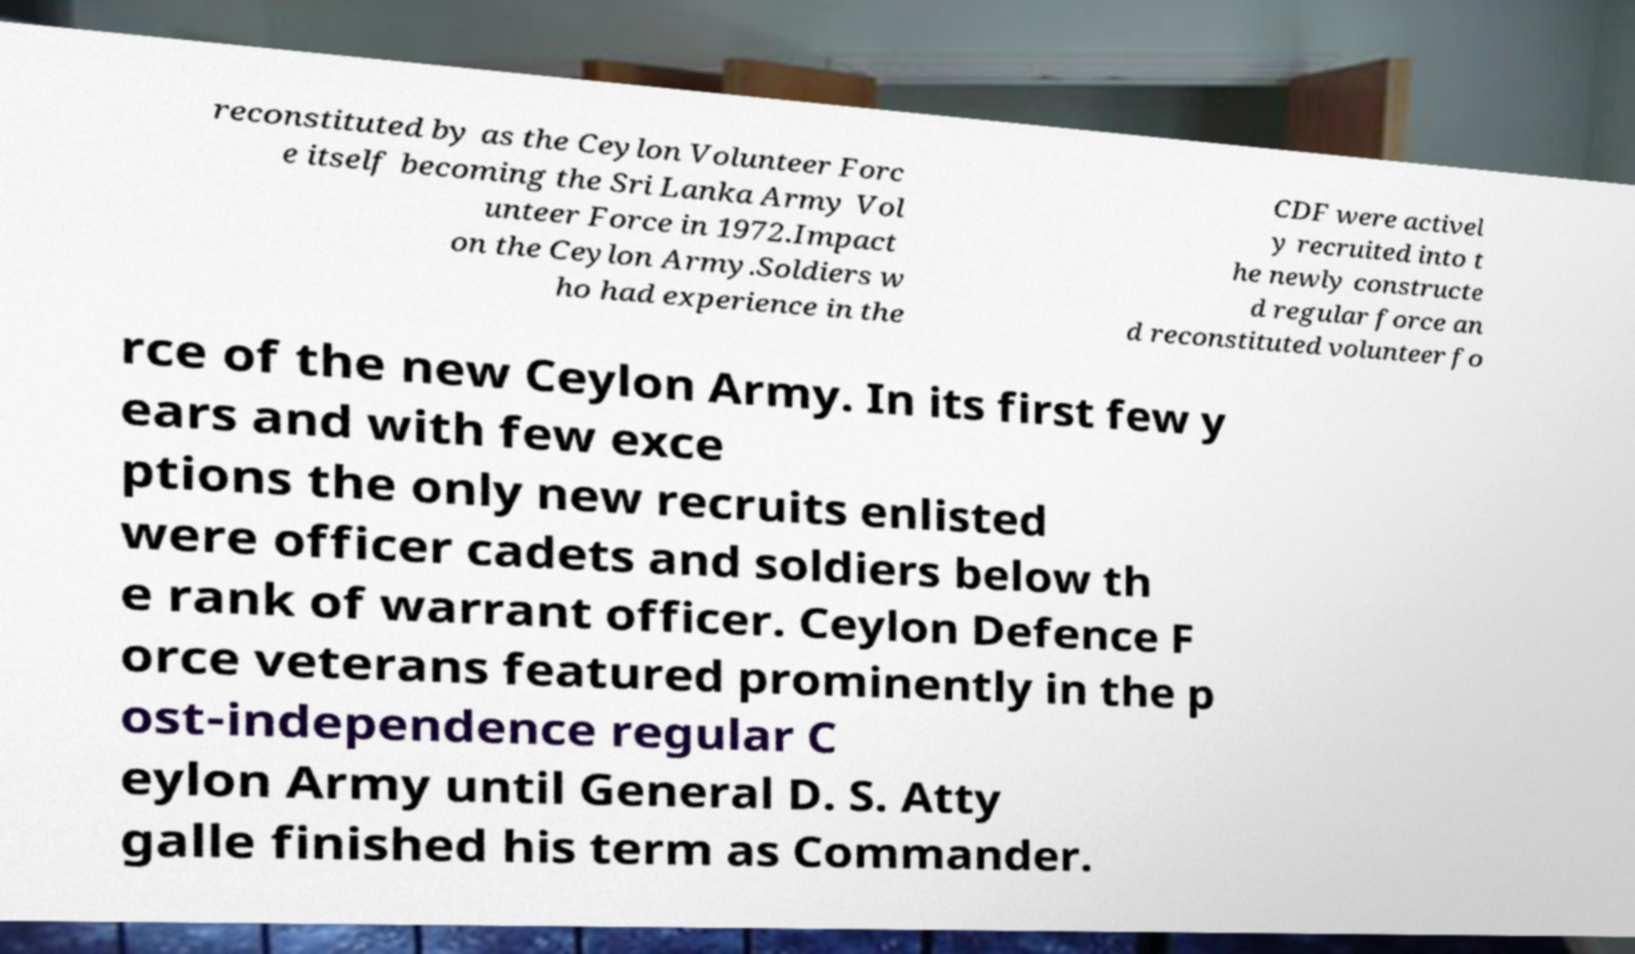What messages or text are displayed in this image? I need them in a readable, typed format. reconstituted by as the Ceylon Volunteer Forc e itself becoming the Sri Lanka Army Vol unteer Force in 1972.Impact on the Ceylon Army.Soldiers w ho had experience in the CDF were activel y recruited into t he newly constructe d regular force an d reconstituted volunteer fo rce of the new Ceylon Army. In its first few y ears and with few exce ptions the only new recruits enlisted were officer cadets and soldiers below th e rank of warrant officer. Ceylon Defence F orce veterans featured prominently in the p ost-independence regular C eylon Army until General D. S. Atty galle finished his term as Commander. 